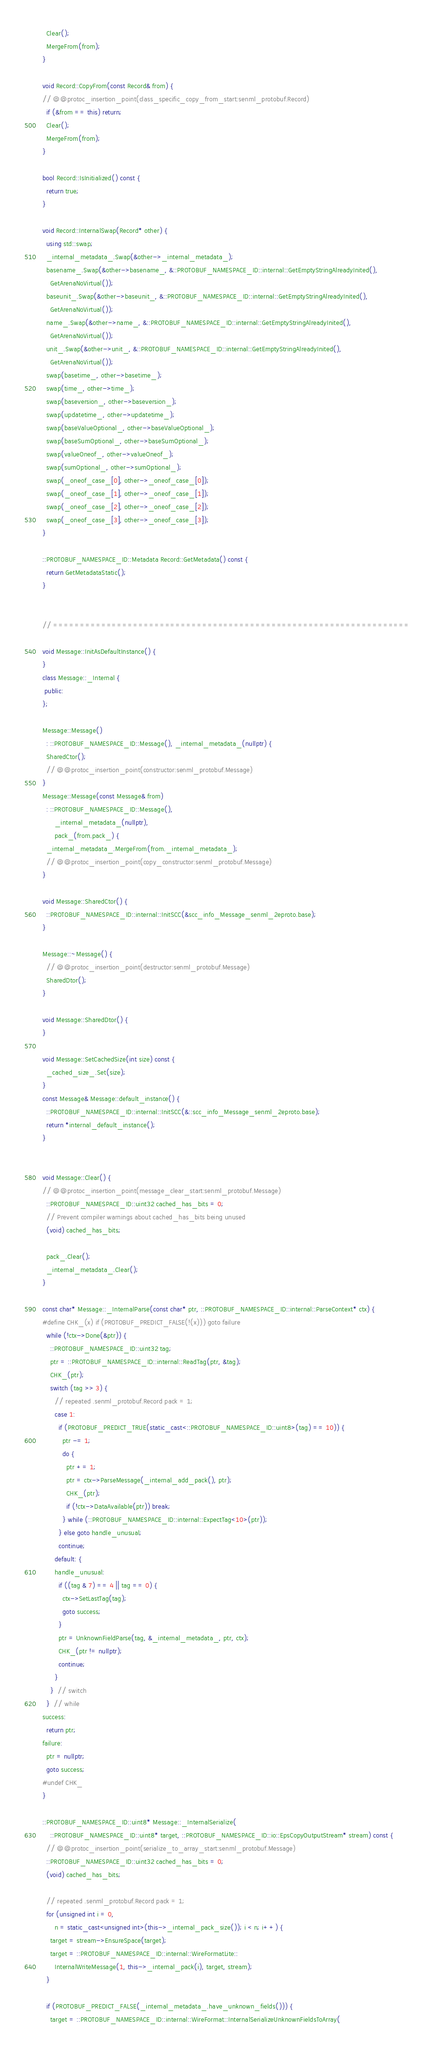Convert code to text. <code><loc_0><loc_0><loc_500><loc_500><_C++_>  Clear();
  MergeFrom(from);
}

void Record::CopyFrom(const Record& from) {
// @@protoc_insertion_point(class_specific_copy_from_start:senml_protobuf.Record)
  if (&from == this) return;
  Clear();
  MergeFrom(from);
}

bool Record::IsInitialized() const {
  return true;
}

void Record::InternalSwap(Record* other) {
  using std::swap;
  _internal_metadata_.Swap(&other->_internal_metadata_);
  basename_.Swap(&other->basename_, &::PROTOBUF_NAMESPACE_ID::internal::GetEmptyStringAlreadyInited(),
    GetArenaNoVirtual());
  baseunit_.Swap(&other->baseunit_, &::PROTOBUF_NAMESPACE_ID::internal::GetEmptyStringAlreadyInited(),
    GetArenaNoVirtual());
  name_.Swap(&other->name_, &::PROTOBUF_NAMESPACE_ID::internal::GetEmptyStringAlreadyInited(),
    GetArenaNoVirtual());
  unit_.Swap(&other->unit_, &::PROTOBUF_NAMESPACE_ID::internal::GetEmptyStringAlreadyInited(),
    GetArenaNoVirtual());
  swap(basetime_, other->basetime_);
  swap(time_, other->time_);
  swap(baseversion_, other->baseversion_);
  swap(updatetime_, other->updatetime_);
  swap(baseValueOptional_, other->baseValueOptional_);
  swap(baseSumOptional_, other->baseSumOptional_);
  swap(valueOneof_, other->valueOneof_);
  swap(sumOptional_, other->sumOptional_);
  swap(_oneof_case_[0], other->_oneof_case_[0]);
  swap(_oneof_case_[1], other->_oneof_case_[1]);
  swap(_oneof_case_[2], other->_oneof_case_[2]);
  swap(_oneof_case_[3], other->_oneof_case_[3]);
}

::PROTOBUF_NAMESPACE_ID::Metadata Record::GetMetadata() const {
  return GetMetadataStatic();
}


// ===================================================================

void Message::InitAsDefaultInstance() {
}
class Message::_Internal {
 public:
};

Message::Message()
  : ::PROTOBUF_NAMESPACE_ID::Message(), _internal_metadata_(nullptr) {
  SharedCtor();
  // @@protoc_insertion_point(constructor:senml_protobuf.Message)
}
Message::Message(const Message& from)
  : ::PROTOBUF_NAMESPACE_ID::Message(),
      _internal_metadata_(nullptr),
      pack_(from.pack_) {
  _internal_metadata_.MergeFrom(from._internal_metadata_);
  // @@protoc_insertion_point(copy_constructor:senml_protobuf.Message)
}

void Message::SharedCtor() {
  ::PROTOBUF_NAMESPACE_ID::internal::InitSCC(&scc_info_Message_senml_2eproto.base);
}

Message::~Message() {
  // @@protoc_insertion_point(destructor:senml_protobuf.Message)
  SharedDtor();
}

void Message::SharedDtor() {
}

void Message::SetCachedSize(int size) const {
  _cached_size_.Set(size);
}
const Message& Message::default_instance() {
  ::PROTOBUF_NAMESPACE_ID::internal::InitSCC(&::scc_info_Message_senml_2eproto.base);
  return *internal_default_instance();
}


void Message::Clear() {
// @@protoc_insertion_point(message_clear_start:senml_protobuf.Message)
  ::PROTOBUF_NAMESPACE_ID::uint32 cached_has_bits = 0;
  // Prevent compiler warnings about cached_has_bits being unused
  (void) cached_has_bits;

  pack_.Clear();
  _internal_metadata_.Clear();
}

const char* Message::_InternalParse(const char* ptr, ::PROTOBUF_NAMESPACE_ID::internal::ParseContext* ctx) {
#define CHK_(x) if (PROTOBUF_PREDICT_FALSE(!(x))) goto failure
  while (!ctx->Done(&ptr)) {
    ::PROTOBUF_NAMESPACE_ID::uint32 tag;
    ptr = ::PROTOBUF_NAMESPACE_ID::internal::ReadTag(ptr, &tag);
    CHK_(ptr);
    switch (tag >> 3) {
      // repeated .senml_protobuf.Record pack = 1;
      case 1:
        if (PROTOBUF_PREDICT_TRUE(static_cast<::PROTOBUF_NAMESPACE_ID::uint8>(tag) == 10)) {
          ptr -= 1;
          do {
            ptr += 1;
            ptr = ctx->ParseMessage(_internal_add_pack(), ptr);
            CHK_(ptr);
            if (!ctx->DataAvailable(ptr)) break;
          } while (::PROTOBUF_NAMESPACE_ID::internal::ExpectTag<10>(ptr));
        } else goto handle_unusual;
        continue;
      default: {
      handle_unusual:
        if ((tag & 7) == 4 || tag == 0) {
          ctx->SetLastTag(tag);
          goto success;
        }
        ptr = UnknownFieldParse(tag, &_internal_metadata_, ptr, ctx);
        CHK_(ptr != nullptr);
        continue;
      }
    }  // switch
  }  // while
success:
  return ptr;
failure:
  ptr = nullptr;
  goto success;
#undef CHK_
}

::PROTOBUF_NAMESPACE_ID::uint8* Message::_InternalSerialize(
    ::PROTOBUF_NAMESPACE_ID::uint8* target, ::PROTOBUF_NAMESPACE_ID::io::EpsCopyOutputStream* stream) const {
  // @@protoc_insertion_point(serialize_to_array_start:senml_protobuf.Message)
  ::PROTOBUF_NAMESPACE_ID::uint32 cached_has_bits = 0;
  (void) cached_has_bits;

  // repeated .senml_protobuf.Record pack = 1;
  for (unsigned int i = 0,
      n = static_cast<unsigned int>(this->_internal_pack_size()); i < n; i++) {
    target = stream->EnsureSpace(target);
    target = ::PROTOBUF_NAMESPACE_ID::internal::WireFormatLite::
      InternalWriteMessage(1, this->_internal_pack(i), target, stream);
  }

  if (PROTOBUF_PREDICT_FALSE(_internal_metadata_.have_unknown_fields())) {
    target = ::PROTOBUF_NAMESPACE_ID::internal::WireFormat::InternalSerializeUnknownFieldsToArray(</code> 